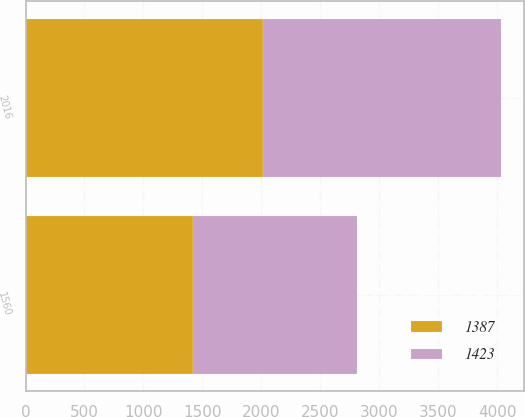<chart> <loc_0><loc_0><loc_500><loc_500><stacked_bar_chart><ecel><fcel>2016<fcel>1560<nl><fcel>1387<fcel>2015<fcel>1423<nl><fcel>1423<fcel>2014<fcel>1387<nl></chart> 